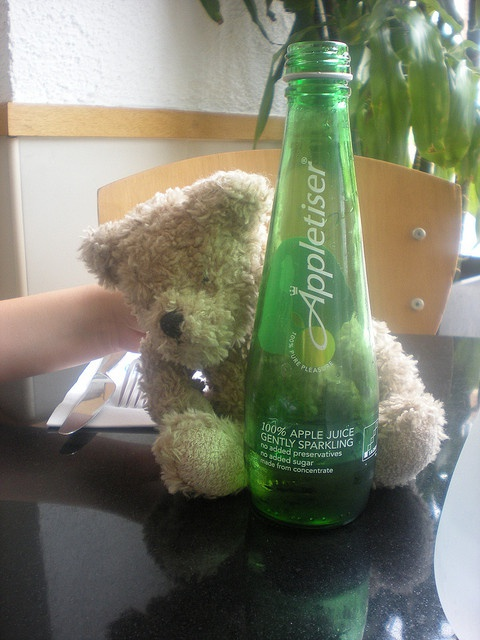Describe the objects in this image and their specific colors. I can see dining table in darkgray, black, gray, and lightgray tones, teddy bear in darkgray, gray, olive, darkgreen, and ivory tones, bottle in darkgray, green, darkgreen, and black tones, potted plant in darkgray, tan, darkgreen, and olive tones, and chair in darkgray, gray, and tan tones in this image. 